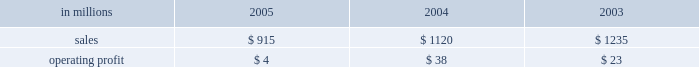Wood products sales in the united states in 2005 of $ 1.6 billion were up 3% ( 3 % ) from $ 1.5 billion in 2004 and 18% ( 18 % ) from $ 1.3 billion in 2003 .
Average price realiza- tions for lumber were up 6% ( 6 % ) and 21% ( 21 % ) in 2005 compared with 2004 and 2003 , respectively .
Lumber sales volumes in 2005 were up 5% ( 5 % ) versus 2004 and 10% ( 10 % ) versus 2003 .
Average sales prices for plywood were down 4% ( 4 % ) from 2004 , but were 15% ( 15 % ) higher than in 2003 .
Plywood sales volumes in 2005 were slightly higher than 2004 and 2003 .
Operating profits in 2005 were 18% ( 18 % ) lower than 2004 , but nearly three times higher than 2003 .
Lower average plywood prices and higher raw material costs more than offset the effects of higher average lumber prices , volume increases and a positive sales mix .
In 2005 , log costs were up 9% ( 9 % ) versus 2004 , negatively im- pacting both plywood and lumber profits .
Lumber and plywood operating costs also reflected substantially higher glue and natural gas costs versus both 2004 and looking forward to the first quarter of 2006 , a con- tinued strong housing market , combined with low prod- uct inventory in the distribution chain , should translate into continued strong lumber and plywood demand .
However , a possible softening of housing starts and higher interest rates later in the year could put down- ward pressure on pricing in the second half of 2006 .
Specialty businesses and other the specialty businesses and other segment in- cludes the operating results of arizona chemical , euro- pean distribution and , prior to its closure in 2003 , our natchez , mississippi chemical cellulose pulp mill .
Also included are certain divested businesses whose results are included in this segment for periods prior to their sale or closure .
This segment 2019s 2005 net sales declined 18% ( 18 % ) and 26% ( 26 % ) from 2004 and 2003 , respectively .
Operating profits in 2005 were down substantially from both 2004 and 2003 .
The decline in sales principally reflects declining contributions from businesses sold or closed .
Operating profits were also affected by higher energy and raw material costs in our chemical business .
Specialty businesses and other in millions 2005 2004 2003 .
Chemicals sales were $ 692 million in 2005 , com- pared with $ 672 million in 2004 and $ 625 million in 2003 .
Although demand was strong for most arizona chemical product lines , operating profits in 2005 were 84% ( 84 % ) and 83% ( 83 % ) lower than in 2004 and 2003 , re- spectively , due to higher energy costs in the u.s. , and higher prices and reduced availability for crude tall oil ( cto ) .
In the united states , energy costs increased 41% ( 41 % ) compared to 2004 due to higher natural gas prices and supply interruption costs .
Cto prices increased 26% ( 26 % ) compared to 2004 , as certain energy users turned to cto as a substitute fuel for high-cost alternative energy sources such as natural gas and fuel oil .
European cto receipts decreased 30% ( 30 % ) compared to 2004 due to lower yields following the finnish paper industry strike and a swedish storm that limited cto throughput and corre- sponding sales volumes .
Other businesses in this operating segment include operations that have been sold , closed , or are held for sale , principally the european distribution business , the oil and gas and mineral royalty business , decorative products , retail packaging , and the natchez chemical cellulose pulp mill .
Sales for these businesses were ap- proximately $ 223 million in 2005 ( mainly european distribution and decorative products ) compared with $ 448 million in 2004 ( mainly european distribution and decorative products ) , and $ 610 million in 2003 .
Liquidity and capital resources overview a major factor in international paper 2019s liquidity and capital resource planning is its generation of operat- ing cash flow , which is highly sensitive to changes in the pricing and demand for our major products .
While changes in key cash operating costs , such as energy and raw material costs , do have an effect on operating cash generation , we believe that our strong focus on cost controls has improved our cash flow generation over an operating cycle .
As a result , we believe that we are well positioned for improvements in operating cash flow should prices and worldwide economic conditions im- prove in the future .
As part of our continuing focus on improving our return on investment , we have focused our capital spending on improving our key platform businesses in north america and in geographic areas with strong growth opportunities .
Spending levels have been kept below the level of depreciation and amortization charges for each of the last three years , and we anticipate con- tinuing this approach in 2006 .
With the low interest rate environment in 2005 , financing activities have focused largely on the repay- ment or refinancing of higher coupon debt , resulting in a net reduction in debt of approximately $ 1.7 billion in 2005 .
We plan to continue this program , with addi- tional reductions anticipated as our previously an- nounced transformation plan progresses in 2006 .
Our liquidity position continues to be strong , with approx- imately $ 3.2 billion of committed liquidity to cover fu- ture short-term cash flow requirements not met by operating cash flows. .
What was the ratio total amount of proceeds from the sales of business entities for european distribution and decorative products in 2004 to 2003? 
Computations: (448 / 610)
Answer: 0.73443. 